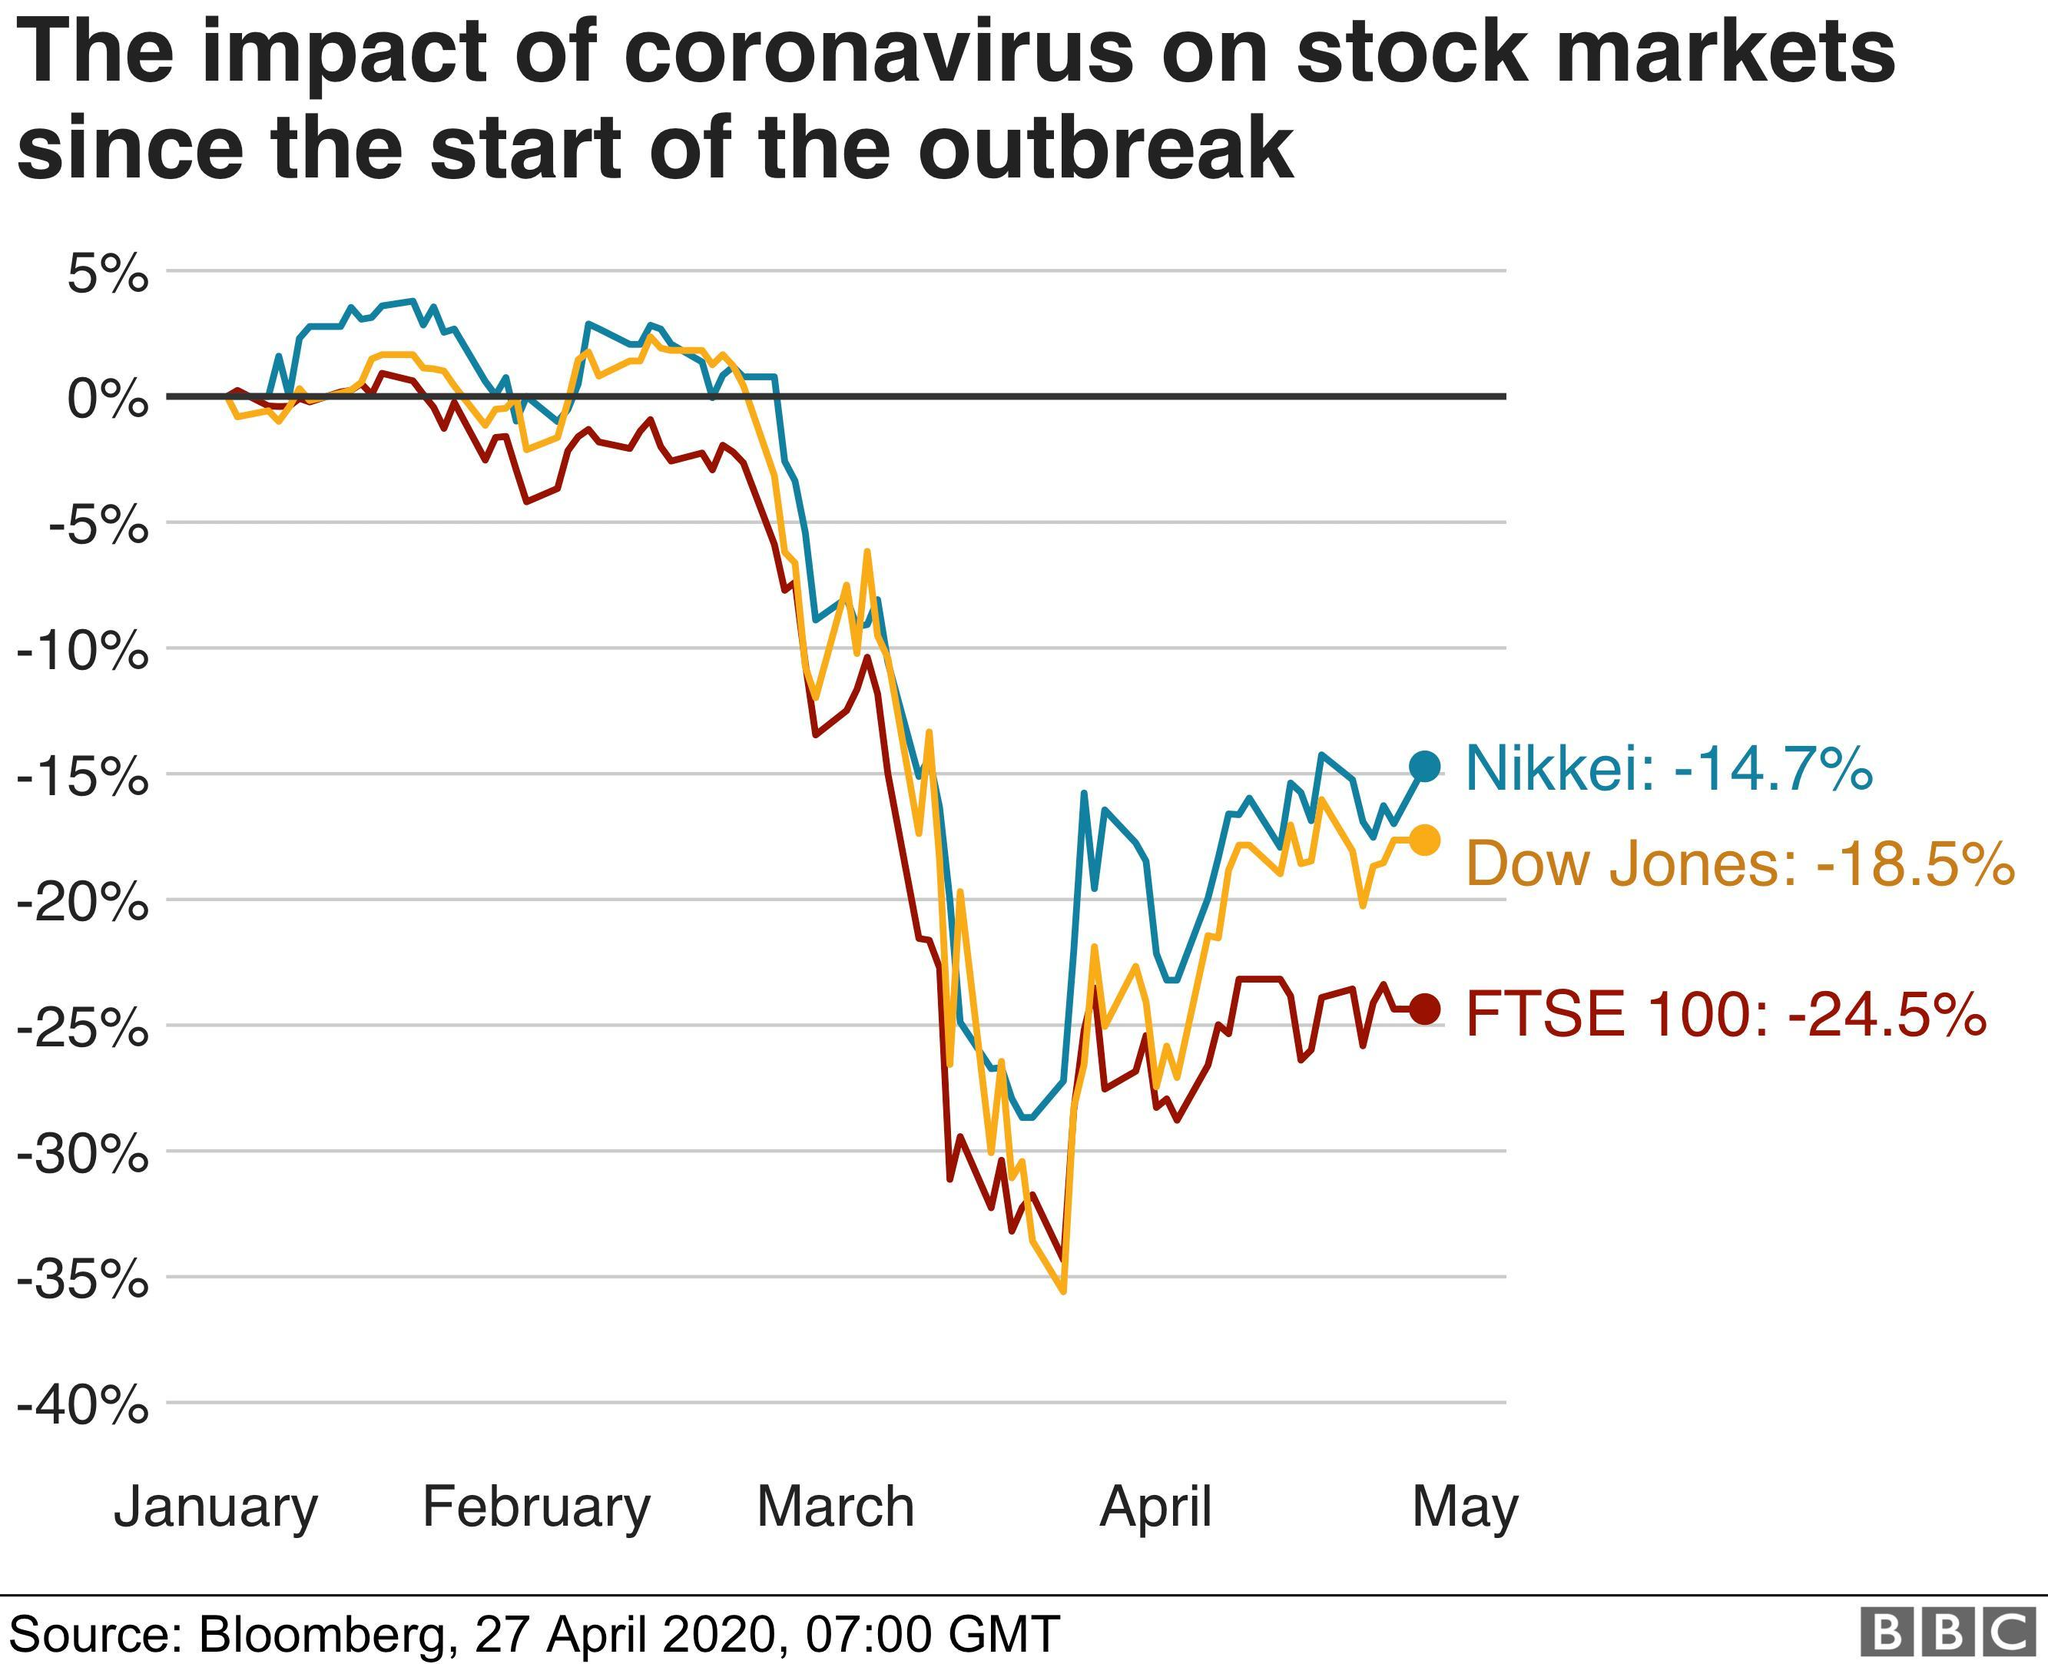How many months performance shown in the graph?
Answer the question with a short phrase. 5 Which Colour of graph represets 'Nikkei' - red, blue, yellow or white? blue How many company names mentioned in the graph? 3 